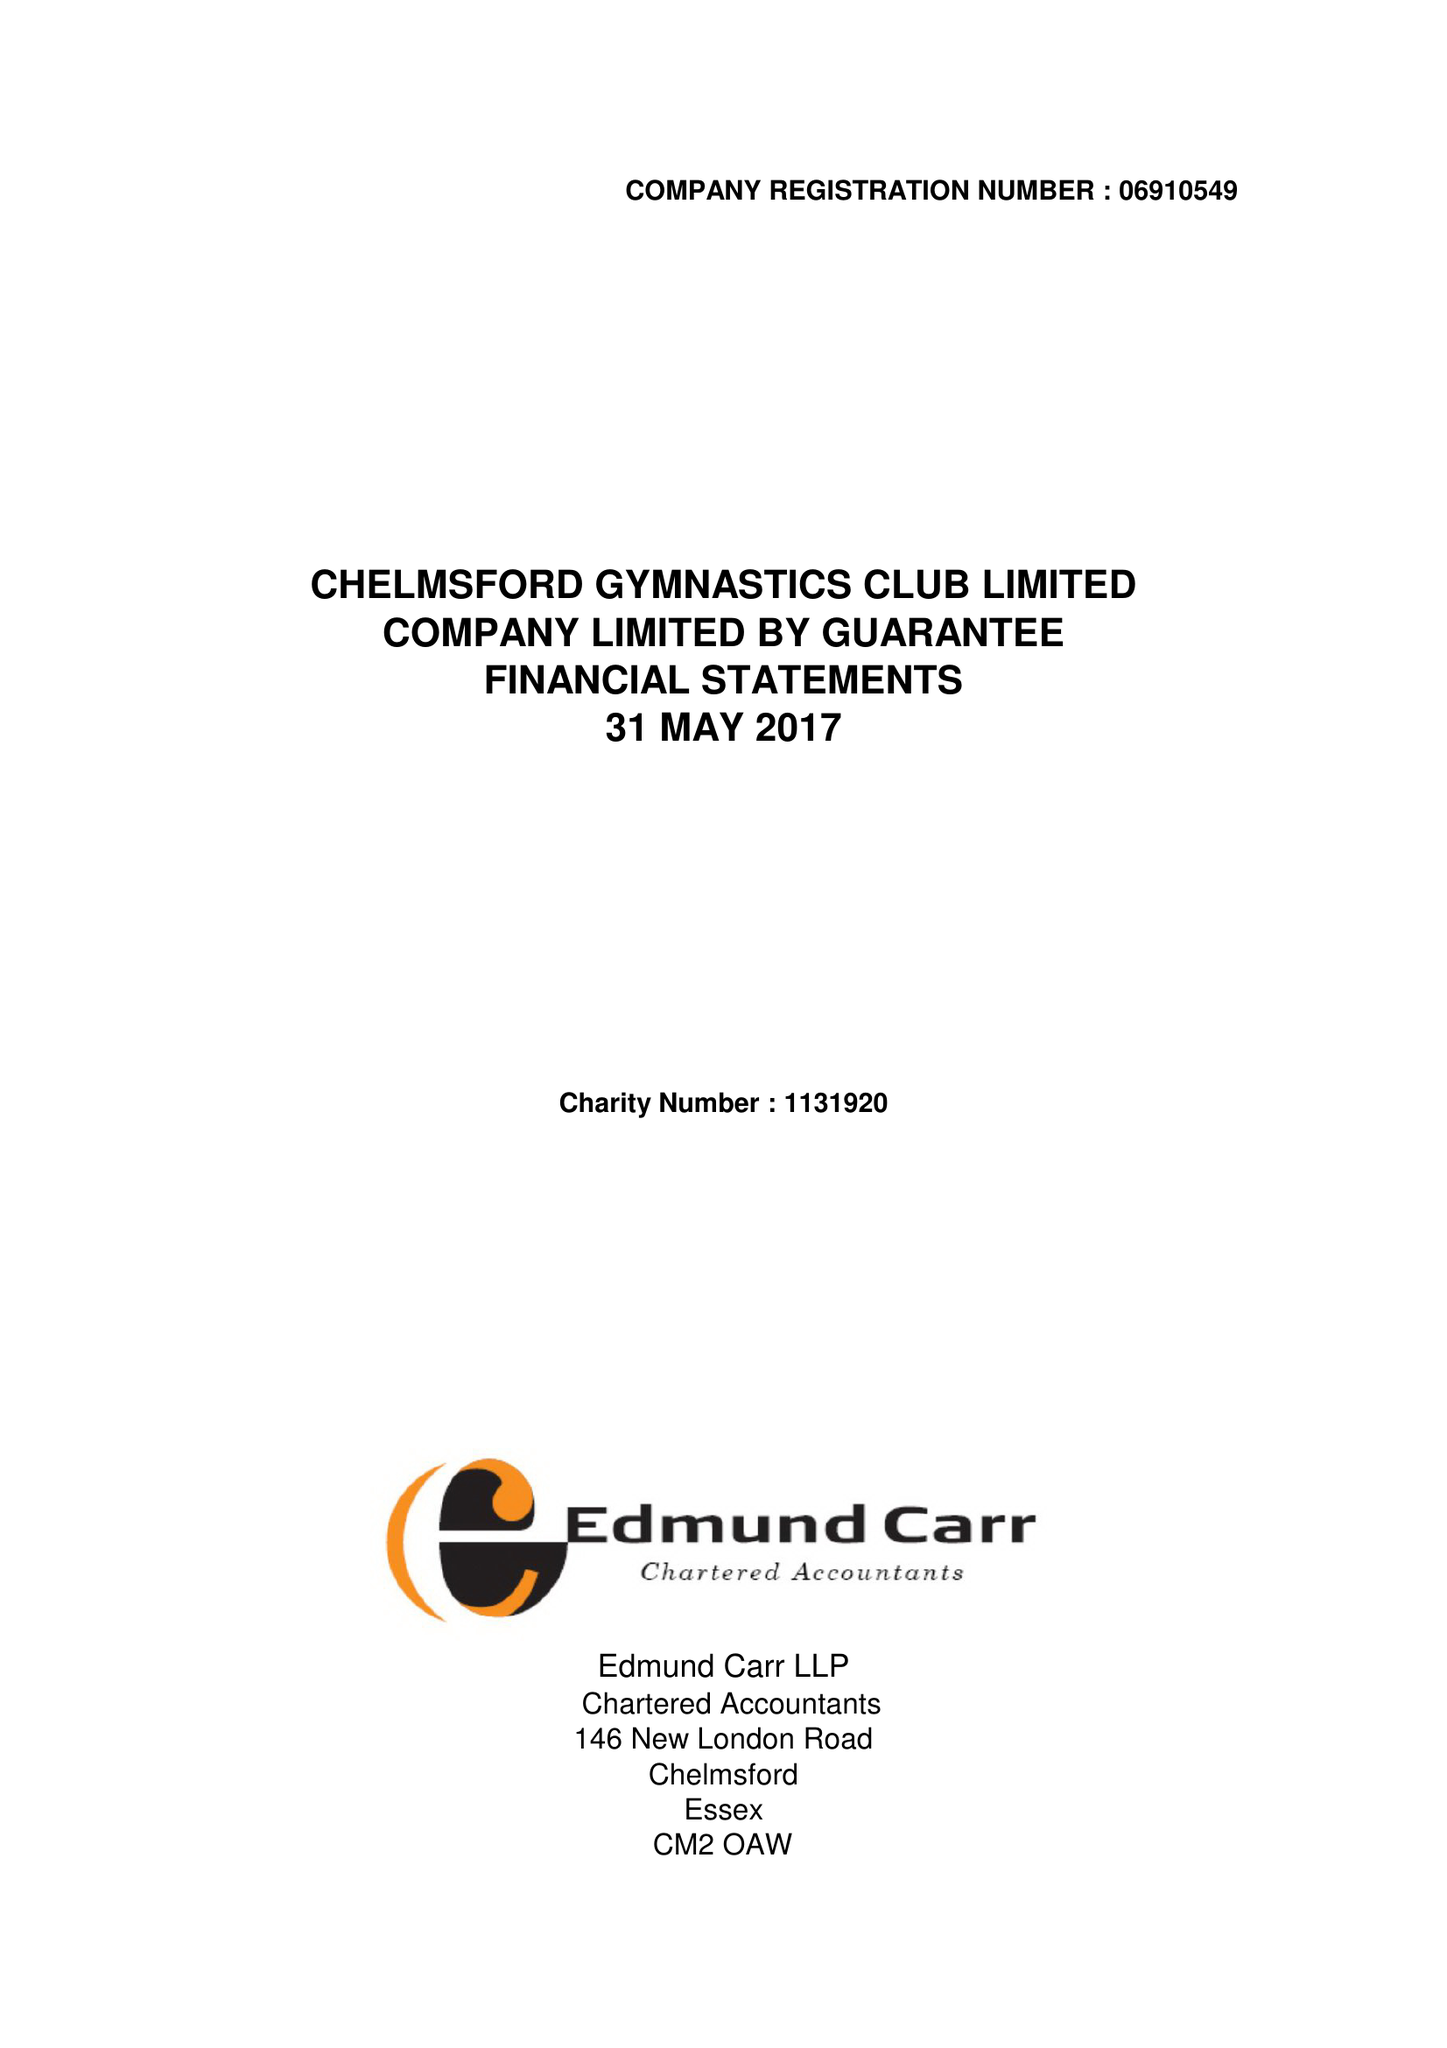What is the value for the address__street_line?
Answer the question using a single word or phrase. 9 THE HEYTHROP 